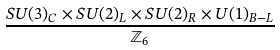Convert formula to latex. <formula><loc_0><loc_0><loc_500><loc_500>\frac { S U ( 3 ) _ { C } \times S U ( 2 ) _ { L } \times S U ( 2 ) _ { R } \times U ( 1 ) _ { B - L } } { \mathbb { Z } _ { 6 } }</formula> 